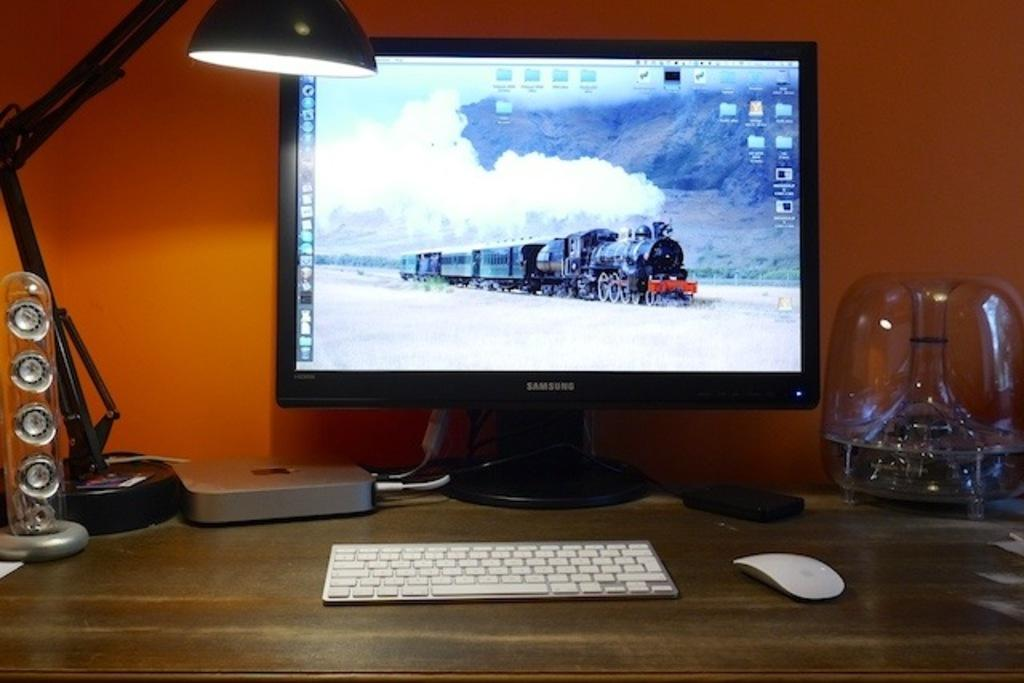<image>
Relay a brief, clear account of the picture shown. Samsung monitor that shows a train in the snow. 